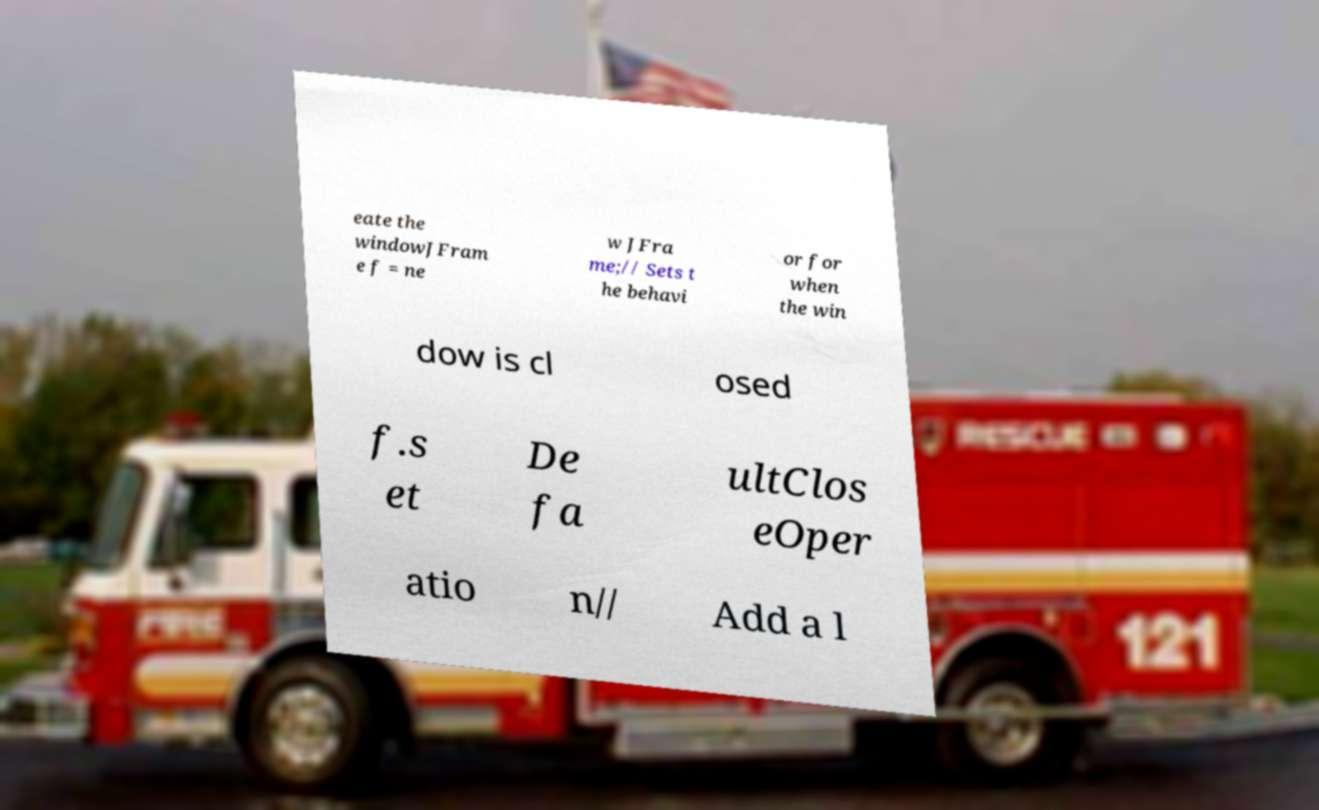For documentation purposes, I need the text within this image transcribed. Could you provide that? eate the windowJFram e f = ne w JFra me;// Sets t he behavi or for when the win dow is cl osed f.s et De fa ultClos eOper atio n// Add a l 